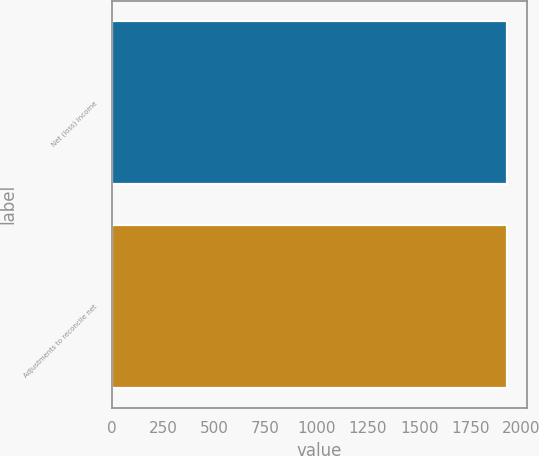Convert chart. <chart><loc_0><loc_0><loc_500><loc_500><bar_chart><fcel>Net (loss) income<fcel>Adjustments to reconcile net<nl><fcel>1931<fcel>1931.1<nl></chart> 